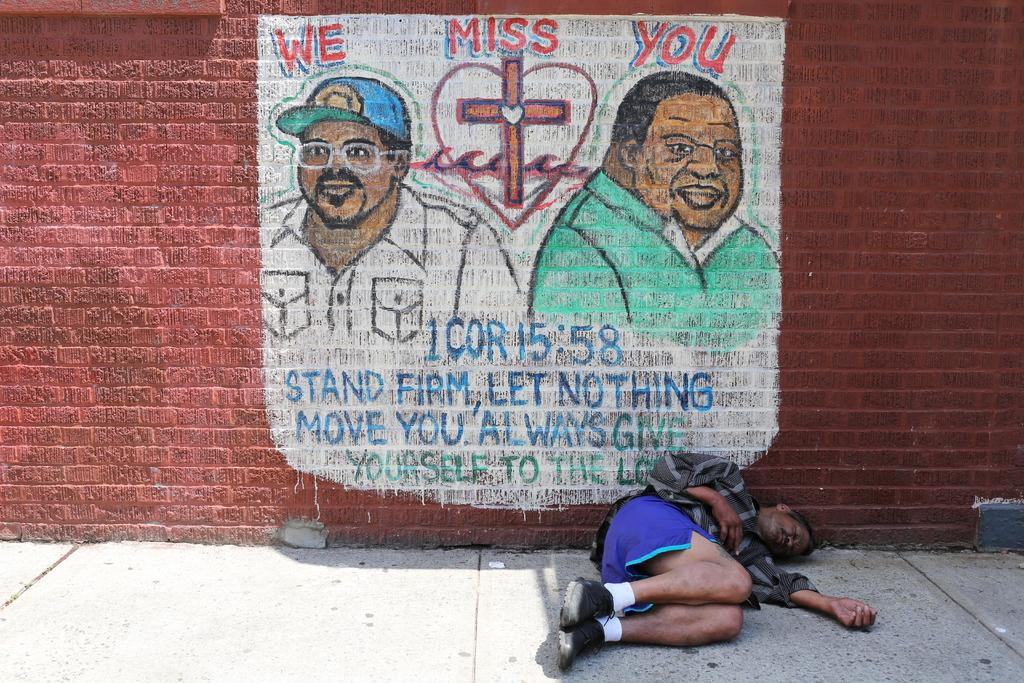<image>
Offer a succinct explanation of the picture presented. A mural is painted on a brick wall that says, "We miss you." 